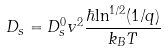Convert formula to latex. <formula><loc_0><loc_0><loc_500><loc_500>D _ { s } = D _ { s } ^ { 0 } v ^ { 2 } \frac { \hbar { \ln } ^ { 1 / 2 } ( 1 / q ) } { k _ { B } T }</formula> 